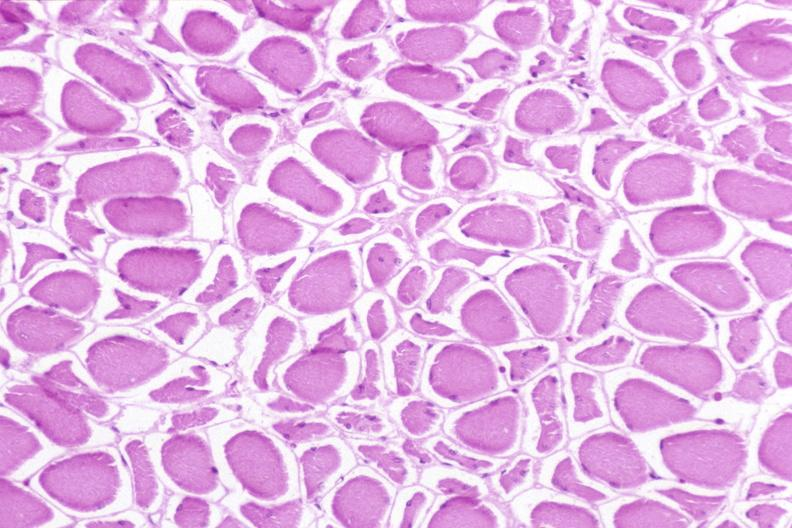s this photo present?
Answer the question using a single word or phrase. No 